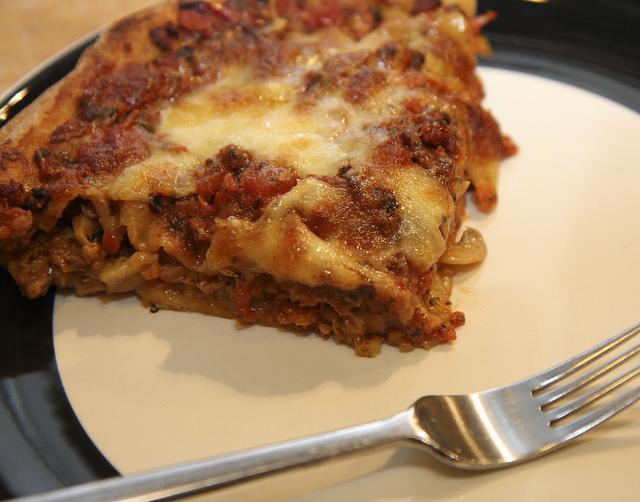How many forks are there?
Give a very brief answer. 1. 